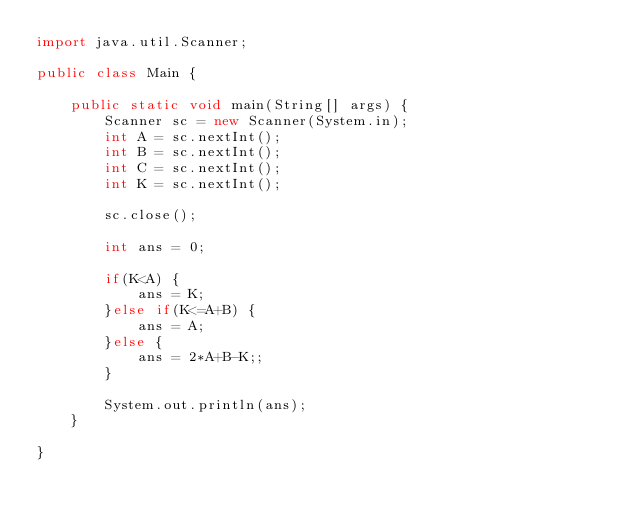<code> <loc_0><loc_0><loc_500><loc_500><_Java_>import java.util.Scanner;

public class Main {

	public static void main(String[] args) {
		Scanner sc = new Scanner(System.in);
		int A = sc.nextInt();
		int B = sc.nextInt();
		int C = sc.nextInt();
		int K = sc.nextInt();
		
		sc.close();
		
		int ans = 0;
		
		if(K<A) {
			ans = K;
		}else if(K<=A+B) {
			ans = A;
		}else {
			ans = 2*A+B-K;;
		}
		
		System.out.println(ans);
	}

}</code> 